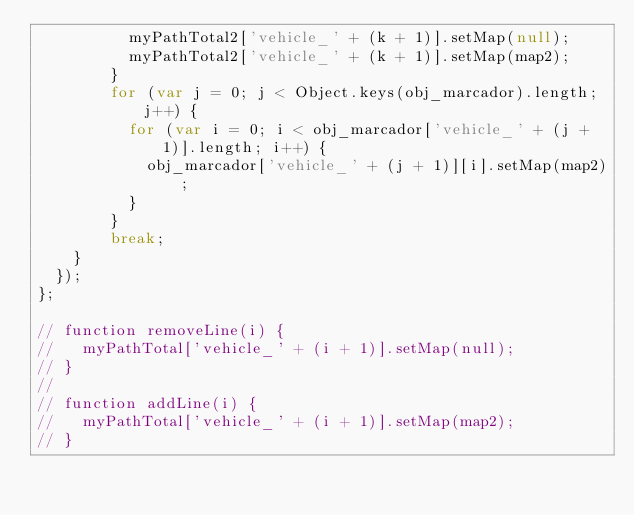<code> <loc_0><loc_0><loc_500><loc_500><_JavaScript_>          myPathTotal2['vehicle_' + (k + 1)].setMap(null);
          myPathTotal2['vehicle_' + (k + 1)].setMap(map2);
        }
        for (var j = 0; j < Object.keys(obj_marcador).length; j++) {
          for (var i = 0; i < obj_marcador['vehicle_' + (j + 1)].length; i++) {
            obj_marcador['vehicle_' + (j + 1)][i].setMap(map2);
          }
        }
        break;
    }
  });
};

// function removeLine(i) {
//   myPathTotal['vehicle_' + (i + 1)].setMap(null);
// }
//
// function addLine(i) {
//   myPathTotal['vehicle_' + (i + 1)].setMap(map2);
// }
</code> 